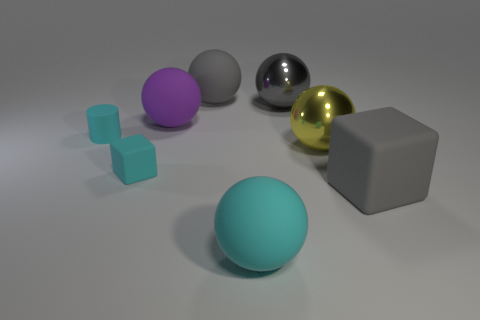What is the material of the large sphere that is the same color as the tiny cylinder?
Make the answer very short. Rubber. There is a rubber sphere that is behind the large gray shiny thing; what is its size?
Provide a succinct answer. Large. What number of objects are either blocks or large rubber balls in front of the big gray matte cube?
Give a very brief answer. 3. How many other things are the same size as the cyan matte ball?
Offer a very short reply. 5. What material is the purple thing that is the same shape as the yellow metal object?
Your answer should be very brief. Rubber. Are there more big things to the right of the yellow metallic sphere than tiny gray shiny spheres?
Offer a very short reply. Yes. What shape is the large gray thing that is made of the same material as the yellow ball?
Provide a succinct answer. Sphere. Are the large thing to the right of the yellow ball and the yellow thing made of the same material?
Ensure brevity in your answer.  No. What shape is the large shiny thing that is the same color as the large rubber cube?
Offer a very short reply. Sphere. There is a matte object that is in front of the big rubber cube; does it have the same color as the matte cube that is behind the gray block?
Ensure brevity in your answer.  Yes. 